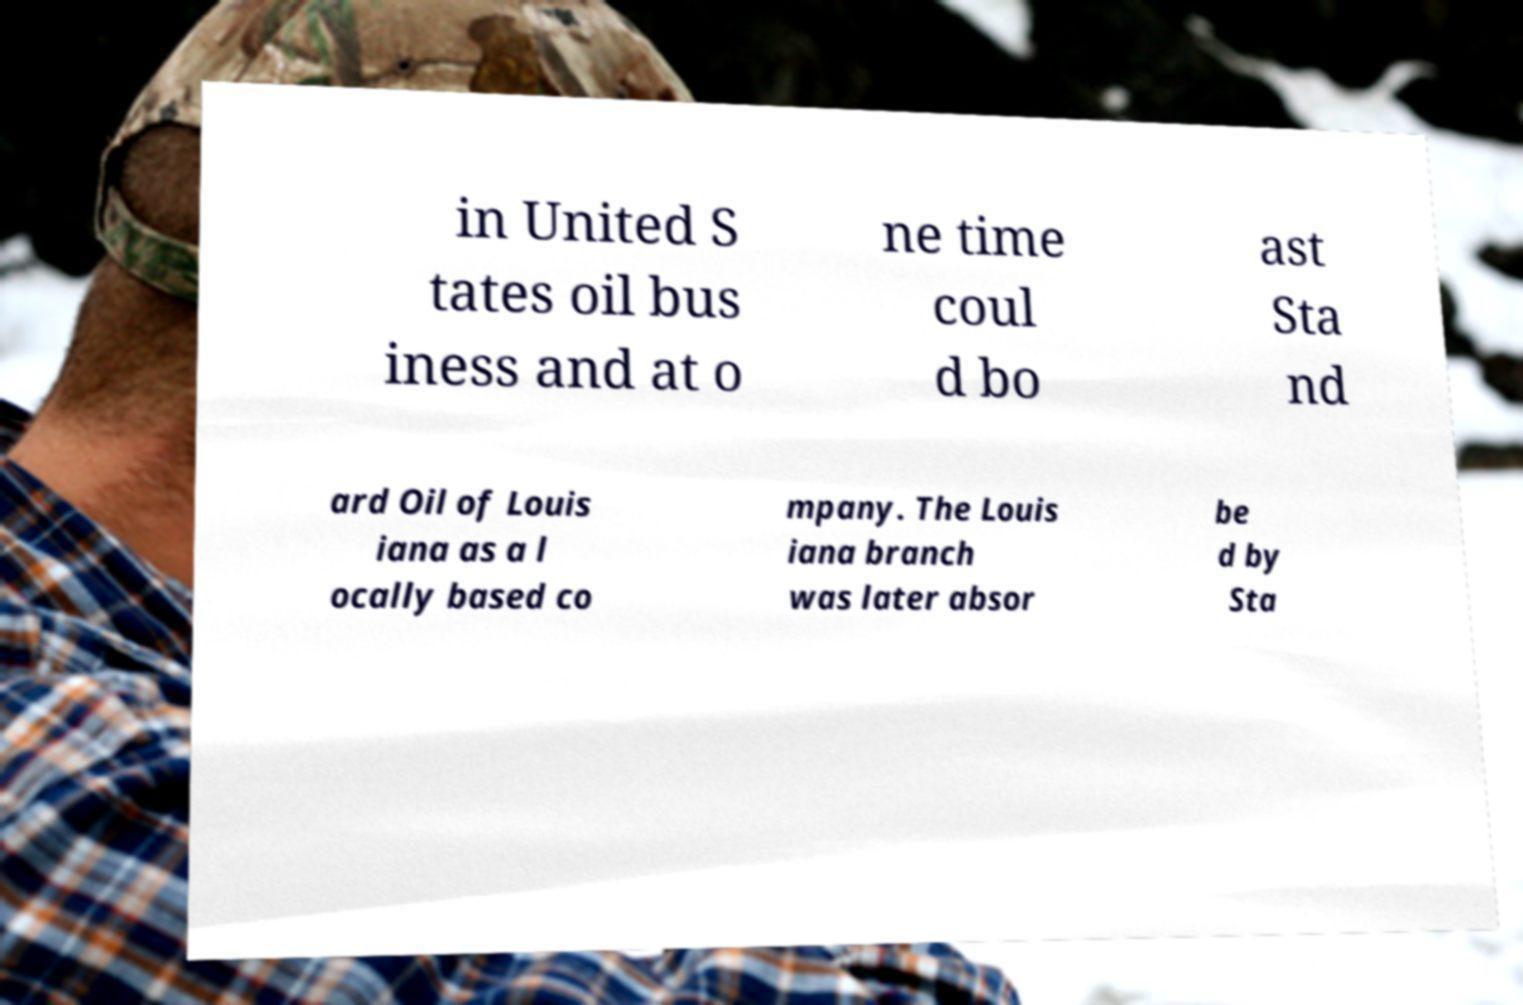I need the written content from this picture converted into text. Can you do that? in United S tates oil bus iness and at o ne time coul d bo ast Sta nd ard Oil of Louis iana as a l ocally based co mpany. The Louis iana branch was later absor be d by Sta 